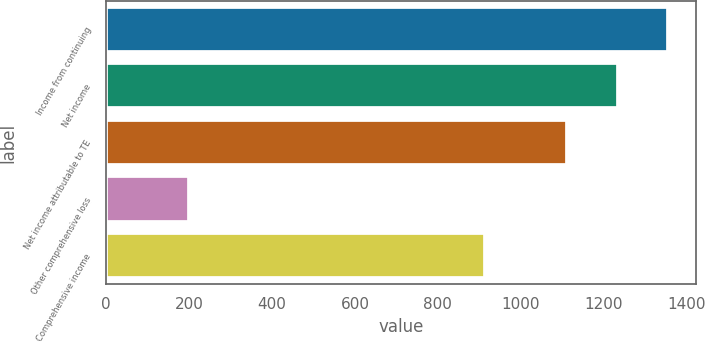Convert chart to OTSL. <chart><loc_0><loc_0><loc_500><loc_500><bar_chart><fcel>Income from continuing<fcel>Net income<fcel>Net income attributable to TE<fcel>Other comprehensive loss<fcel>Comprehensive income<nl><fcel>1355.2<fcel>1233.6<fcel>1112<fcel>199<fcel>913<nl></chart> 